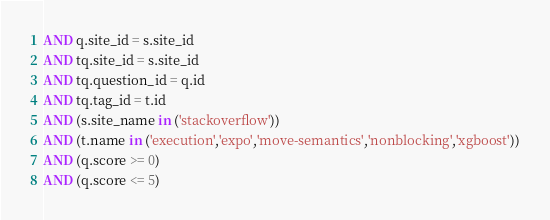Convert code to text. <code><loc_0><loc_0><loc_500><loc_500><_SQL_>AND q.site_id = s.site_id
AND tq.site_id = s.site_id
AND tq.question_id = q.id
AND tq.tag_id = t.id
AND (s.site_name in ('stackoverflow'))
AND (t.name in ('execution','expo','move-semantics','nonblocking','xgboost'))
AND (q.score >= 0)
AND (q.score <= 5)
</code> 